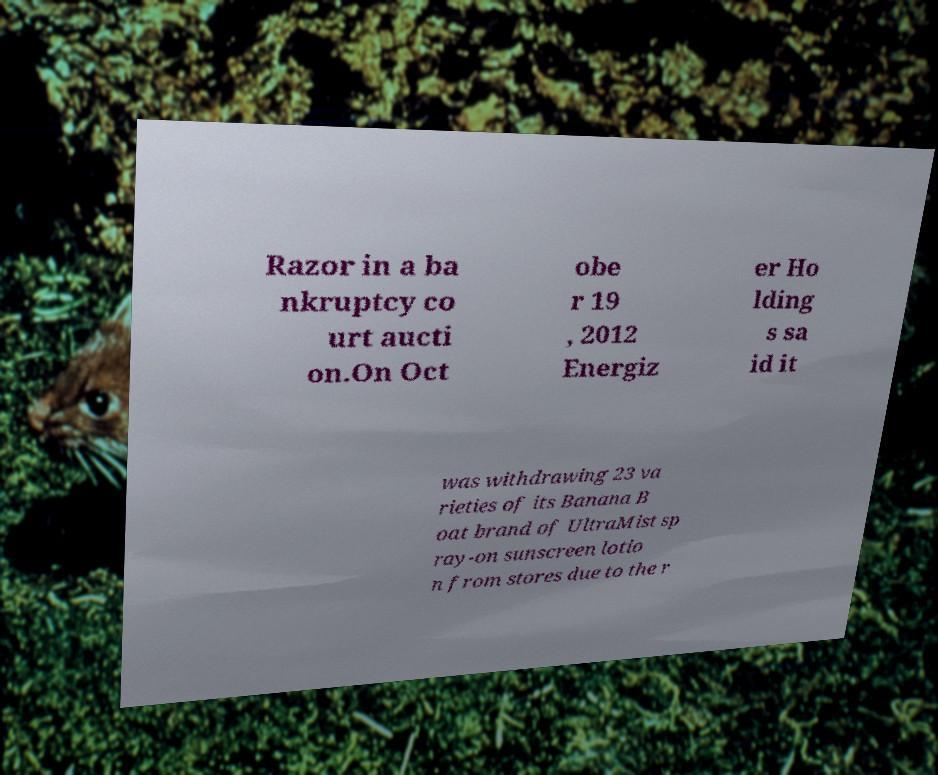Please read and relay the text visible in this image. What does it say? Razor in a ba nkruptcy co urt aucti on.On Oct obe r 19 , 2012 Energiz er Ho lding s sa id it was withdrawing 23 va rieties of its Banana B oat brand of UltraMist sp ray-on sunscreen lotio n from stores due to the r 